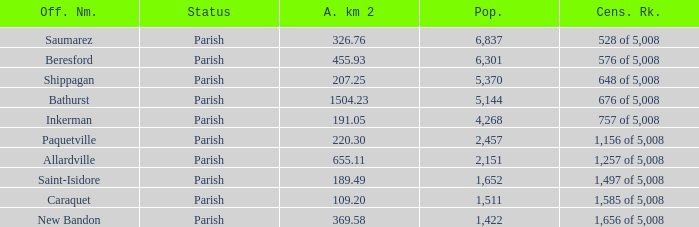What is the Population of the New Bandon Parish with an Area km 2 larger than 326.76? 1422.0. 